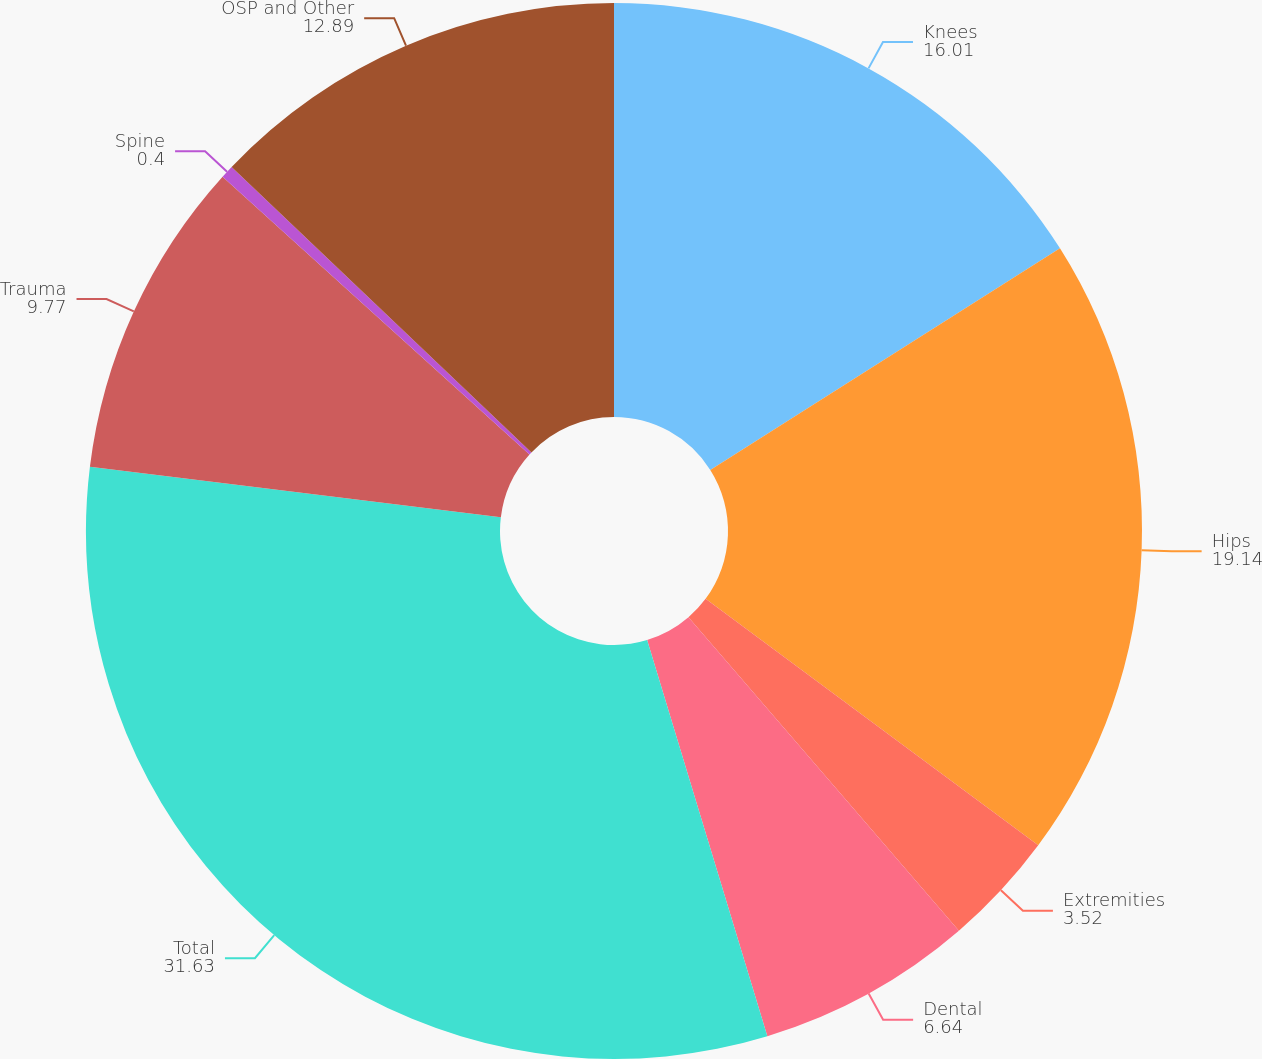Convert chart. <chart><loc_0><loc_0><loc_500><loc_500><pie_chart><fcel>Knees<fcel>Hips<fcel>Extremities<fcel>Dental<fcel>Total<fcel>Trauma<fcel>Spine<fcel>OSP and Other<nl><fcel>16.01%<fcel>19.14%<fcel>3.52%<fcel>6.64%<fcel>31.63%<fcel>9.77%<fcel>0.4%<fcel>12.89%<nl></chart> 